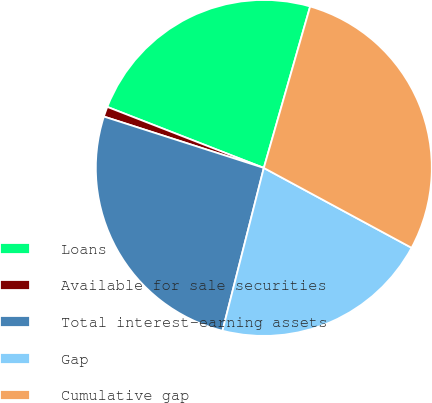Convert chart to OTSL. <chart><loc_0><loc_0><loc_500><loc_500><pie_chart><fcel>Loans<fcel>Available for sale securities<fcel>Total interest-earning assets<fcel>Gap<fcel>Cumulative gap<nl><fcel>23.53%<fcel>0.97%<fcel>25.99%<fcel>21.07%<fcel>28.44%<nl></chart> 